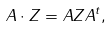<formula> <loc_0><loc_0><loc_500><loc_500>A \cdot Z = A Z A ^ { t } ,</formula> 